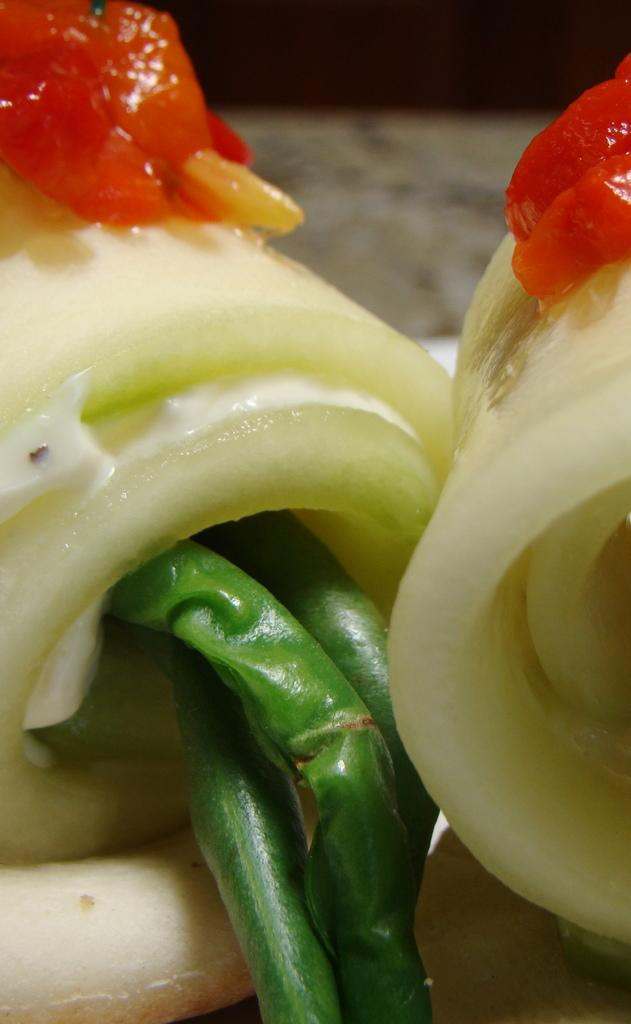What is the main focus of the image? The main focus of the image is a close view of food. What specific ingredients can be seen in the image? Tomatoes and green chilies are visible in the image. What type of creature can be seen crawling on the tomatoes in the image? There are no creatures visible in the image; it only shows tomatoes and green chilies. 